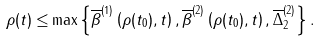<formula> <loc_0><loc_0><loc_500><loc_500>\rho ( t ) \leq & \max \left \{ \overline { \beta } ^ { ( 1 ) } \left ( \rho ( t _ { 0 } ) , t \right ) , \overline { \beta } ^ { ( 2 ) } \left ( \rho ( t _ { 0 } ) , t \right ) , \overline { \Delta } _ { 2 } ^ { ( 2 ) } \right \} .</formula> 